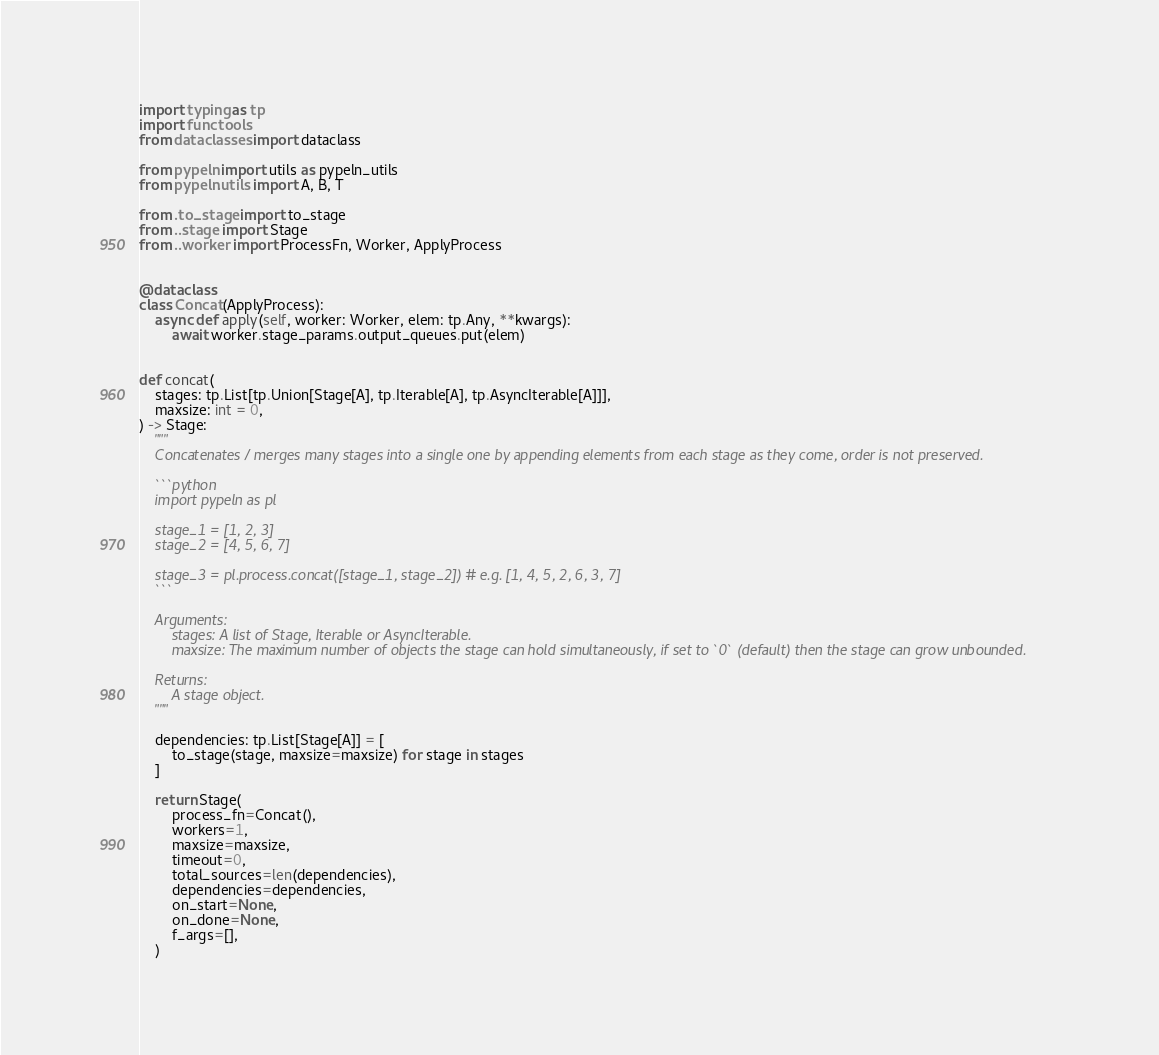Convert code to text. <code><loc_0><loc_0><loc_500><loc_500><_Python_>import typing as tp
import functools
from dataclasses import dataclass

from pypeln import utils as pypeln_utils
from pypeln.utils import A, B, T

from .to_stage import to_stage
from ..stage import Stage
from ..worker import ProcessFn, Worker, ApplyProcess


@dataclass
class Concat(ApplyProcess):
    async def apply(self, worker: Worker, elem: tp.Any, **kwargs):
        await worker.stage_params.output_queues.put(elem)


def concat(
    stages: tp.List[tp.Union[Stage[A], tp.Iterable[A], tp.AsyncIterable[A]]],
    maxsize: int = 0,
) -> Stage:
    """
    Concatenates / merges many stages into a single one by appending elements from each stage as they come, order is not preserved.

    ```python
    import pypeln as pl

    stage_1 = [1, 2, 3]
    stage_2 = [4, 5, 6, 7]

    stage_3 = pl.process.concat([stage_1, stage_2]) # e.g. [1, 4, 5, 2, 6, 3, 7]
    ```

    Arguments:
        stages: A list of Stage, Iterable or AsyncIterable.
        maxsize: The maximum number of objects the stage can hold simultaneously, if set to `0` (default) then the stage can grow unbounded.

    Returns:
        A stage object.
    """

    dependencies: tp.List[Stage[A]] = [
        to_stage(stage, maxsize=maxsize) for stage in stages
    ]

    return Stage(
        process_fn=Concat(),
        workers=1,
        maxsize=maxsize,
        timeout=0,
        total_sources=len(dependencies),
        dependencies=dependencies,
        on_start=None,
        on_done=None,
        f_args=[],
    )
</code> 